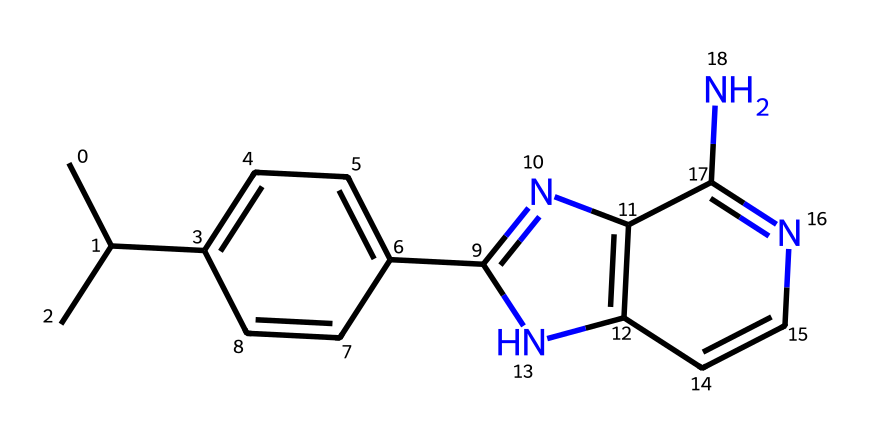What is the total number of carbon atoms in this chemical? By analyzing the SMILES representation and counting each carbon (C) atom, we can find the total. In the structure, there are 11 carbon atoms present.
Answer: 11 How many nitrogen atoms are in this chemical? In the SMILES, we can identify the nitrogen (N) atoms by counting each instance of 'N'. There are 4 nitrogen atoms in this chemical structure.
Answer: 4 What is the primary functional group present in this drug? The presence of nitrogen atoms and the overall structure suggests that this drug contains an amine functional group, common in many pharmaceuticals including anti-malarials.
Answer: amine Which part of the structure is responsible for the drug's activity? The fused ring structure, particularly the nitrogen-containing heterocycles, is responsible for the drug's biological activity, as these features often interact with biological targets.
Answer: fused ring structure What makes this substance useful against malaria? The molecular structure, specifically the nitrogen heterocycles and their ability to interfere with malarial parasite biochemistry, renders this compound effective against malaria.
Answer: interference with malarial parasite Is this chemical a type of alkaloid? Observing the structure, it contains multiple nitrogen atoms and has a characteristic ring system common in alkaloids, confirming that it is an alkaloid type drug.
Answer: alkaloid 